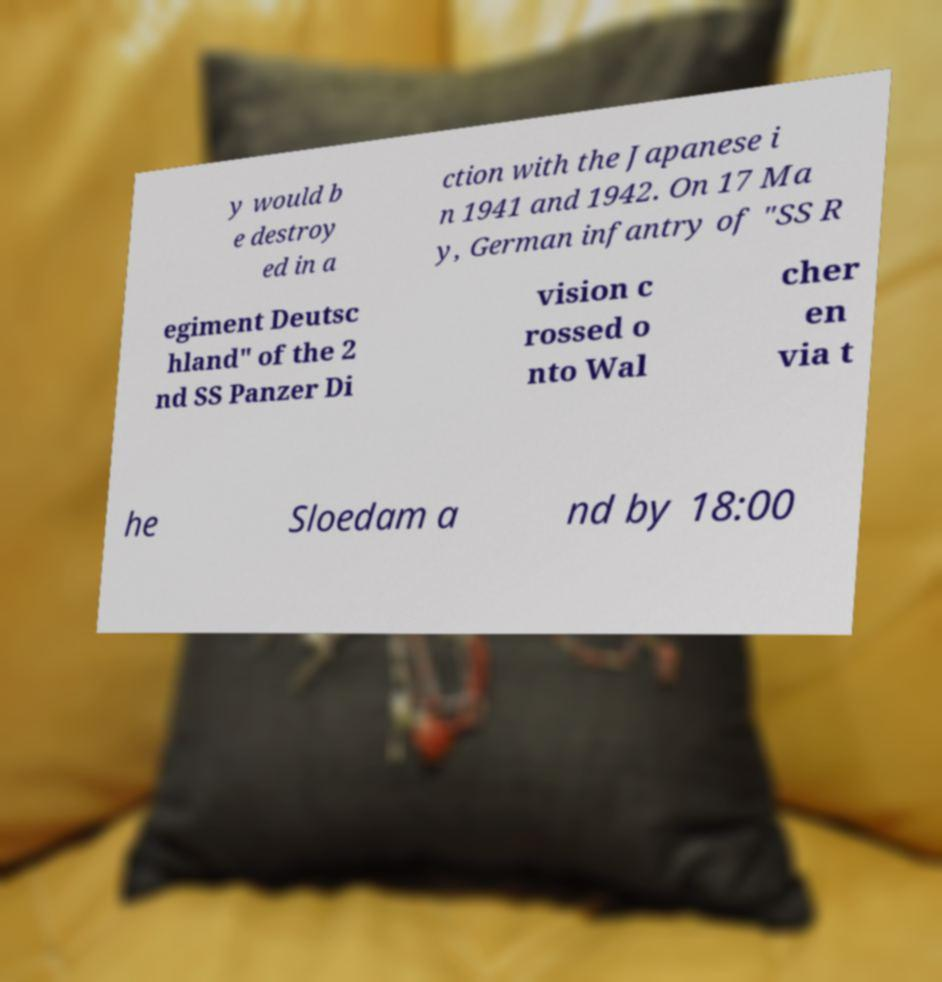For documentation purposes, I need the text within this image transcribed. Could you provide that? y would b e destroy ed in a ction with the Japanese i n 1941 and 1942. On 17 Ma y, German infantry of "SS R egiment Deutsc hland" of the 2 nd SS Panzer Di vision c rossed o nto Wal cher en via t he Sloedam a nd by 18:00 